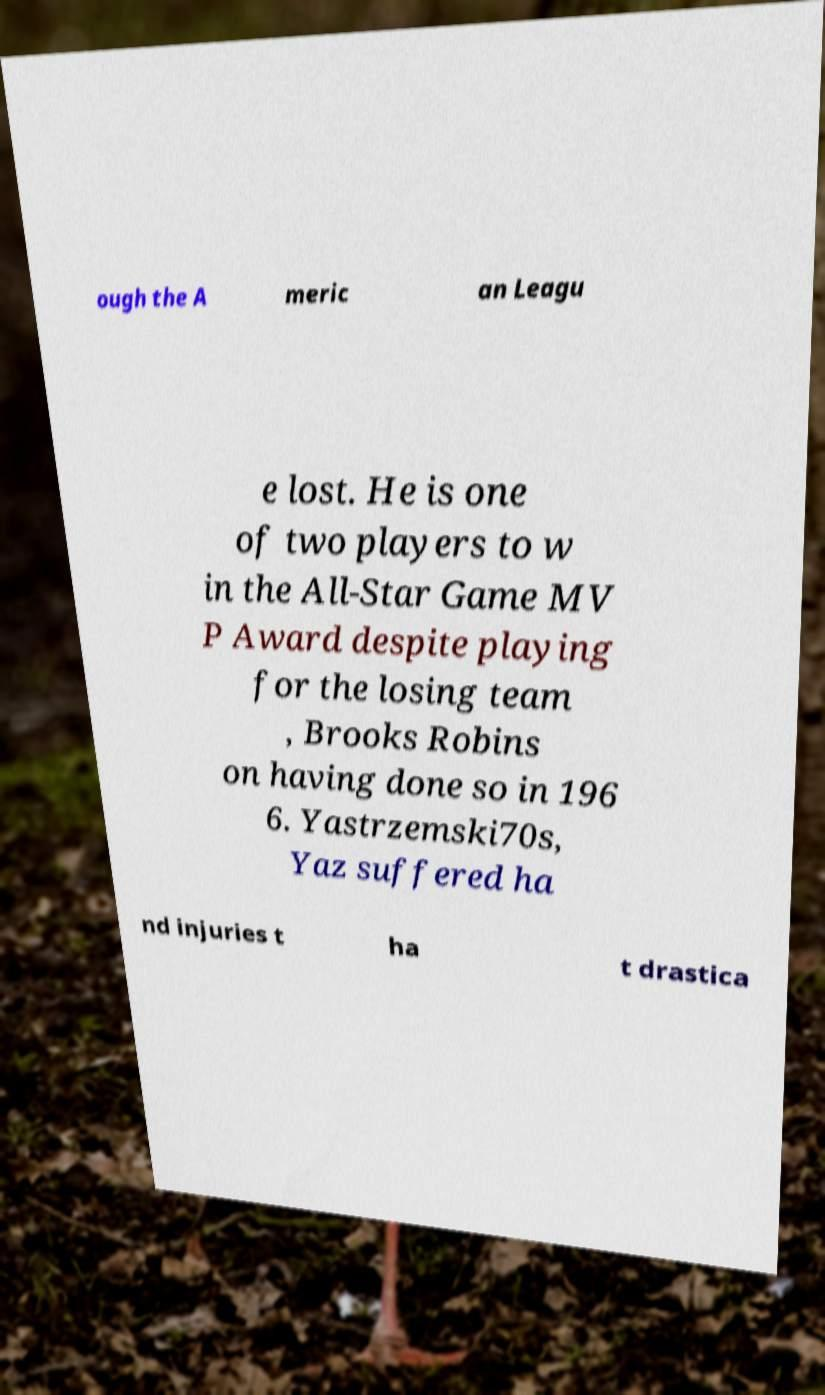For documentation purposes, I need the text within this image transcribed. Could you provide that? ough the A meric an Leagu e lost. He is one of two players to w in the All-Star Game MV P Award despite playing for the losing team , Brooks Robins on having done so in 196 6. Yastrzemski70s, Yaz suffered ha nd injuries t ha t drastica 